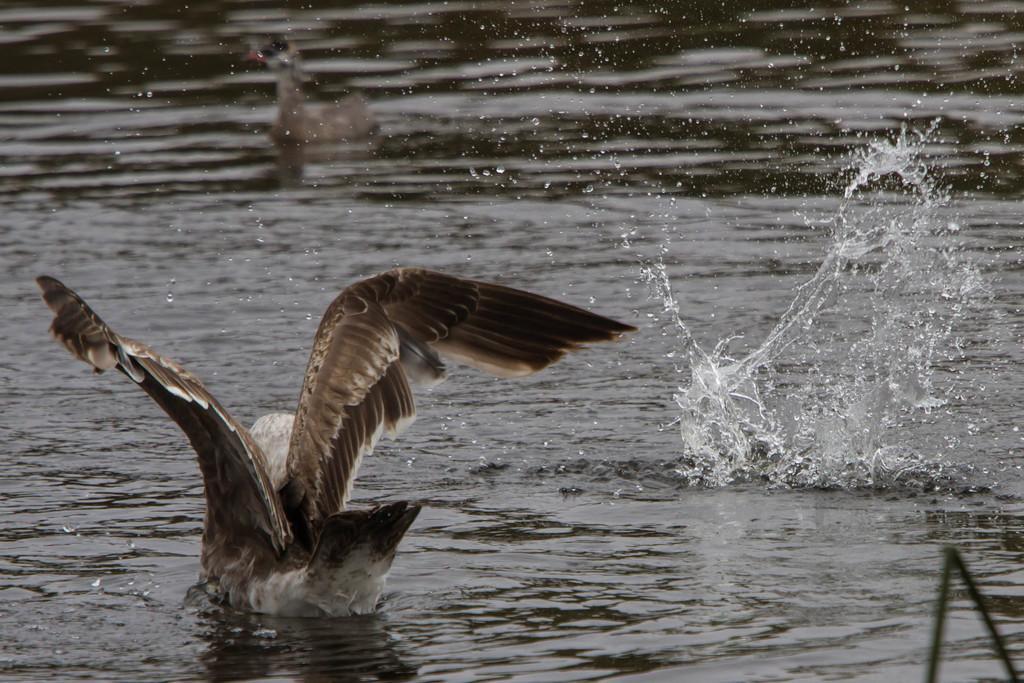Please provide a concise description of this image. In the image in the center we can see one bird in the water,which is in brown and white color. 